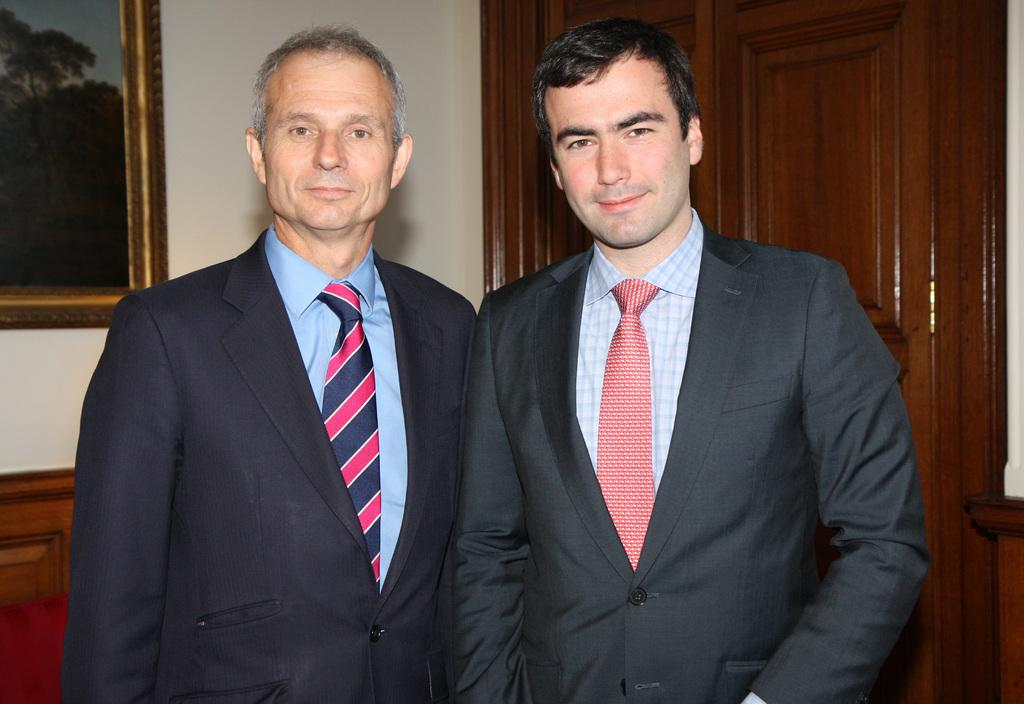What can be seen in the foreground of the image? There are persons standing in the front of the image. How are the persons in the image expressing themselves? The persons are smiling. What is located on the wall in the background of the image? There is a frame on the wall in the background of the image. What type of furniture is on the right side of the image? There is a cupboard on the right side of the image. What grade did the person in the image receive for their performance? There is no indication of a performance or grade in the image; it simply shows persons standing and smiling. Who is the coach of the team in the image? There is no team or coach present in the image. 